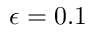Convert formula to latex. <formula><loc_0><loc_0><loc_500><loc_500>\epsilon = 0 . 1</formula> 